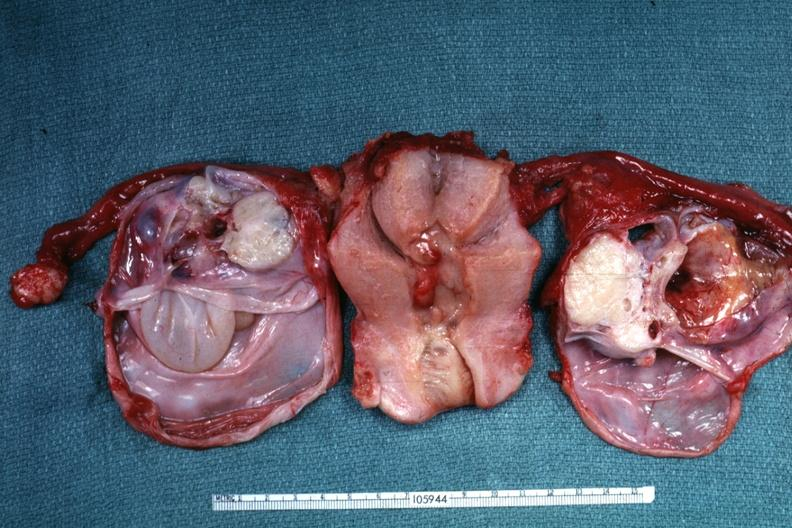s cytomegalovirus present?
Answer the question using a single word or phrase. No 